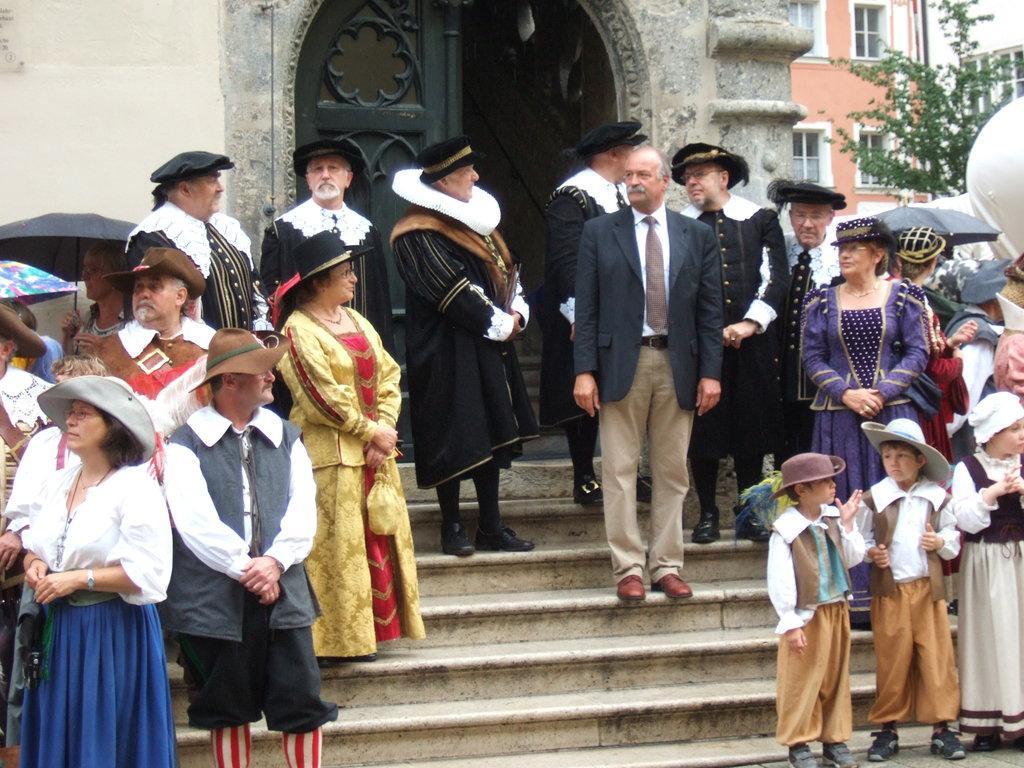How would you summarize this image in a sentence or two? In this image I can see number of persons are standing on stairs. In the background I can see a tree, few buildings, few windows of the buildings and an umbrella which is black in color. 